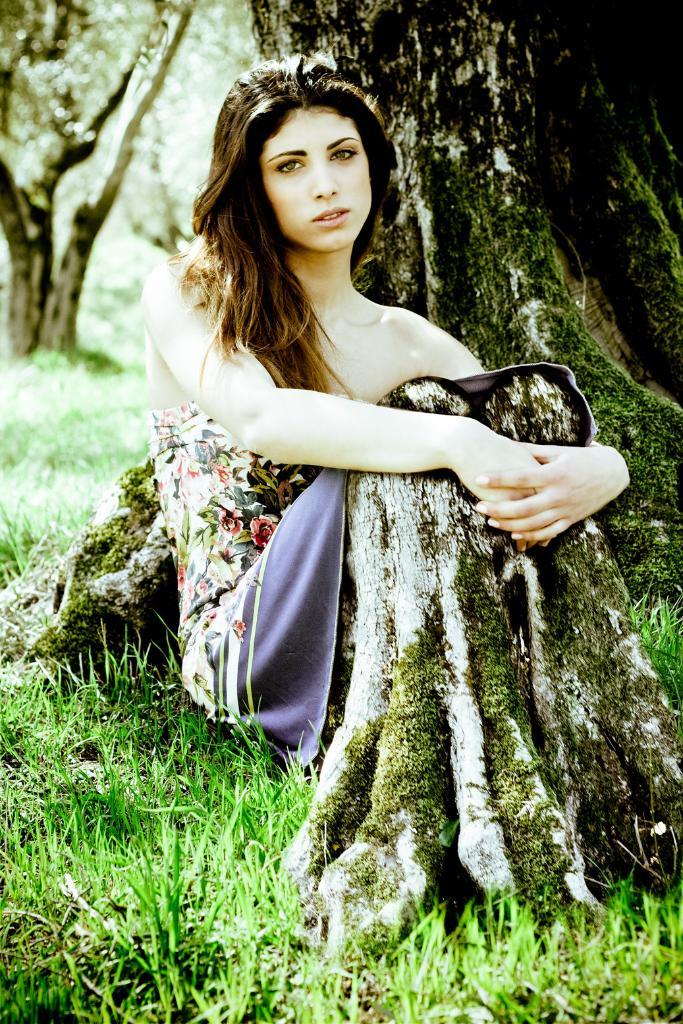Who is the main subject in the image? There is a woman in the image. What is the woman doing in the image? The woman is sitting on the grass. What can be seen in the background of the image? There are trees visible in the background of the image. What type of cheese is the woman holding in the image? There is no cheese present in the image; the woman is sitting on the grass with no visible objects in her hands. 